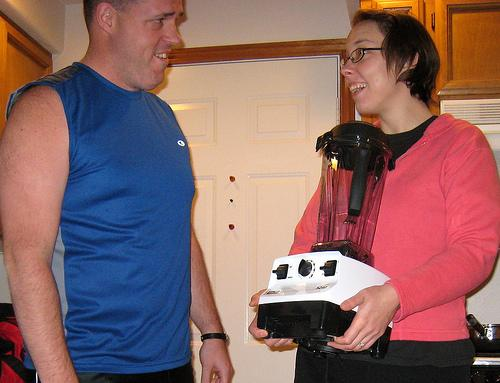Identify the objects near the man and describe their colors. The man is wearing a black watch on his left wrist, and he has on blue shirt with gray trim and black pants. There is a white door with a peep hole and wooden frame behind him. What are the overall emotions of the man and woman in the image, and how can you conclude that? Both the man and woman appear happy and engaged with each other's presence. The man is looking at the woman, while the woman is smiling broadly, indicating a sense of happiness and contentment. Identify any kitchen appliances, furniture or cookware depicted in the image. A black and white blender, a white door behind the people, wood kitchen cabinets, and a saucepan on the stove behind the woman are visible in the image. What can you tell about the apparel of the people in the photograph? A man wearing a blue-gray muscle shirt and a woman in a pink sweater are standing in the kitchen. The woman is wearing glasses and holding an electric blender. How many people are in the image and what are their appearances? There are two people in the image: a woman with short brown hair, glasses, and a pink sweater, and a man with a blue shirt and black pants. They are both standing in a kitchen. Describe the clothing items worn by the woman in the image. The woman is wearing a pink sweatshirt, a black shirt, and a red sweater. She also has on a wedding ring and a pair of eyeglasses. What are the two main colors of the electric blender? The electric blender is primarily black and white. What does the woman seem to be happy about while holding a kitchen appliance? The woman is smiling happily as she holds a black and white electric blender that she may be using in the kitchen. Describe the object that the woman is holding and provide any unique features of it. The woman is holding an electric blender that is black and white with a distinct knob on it. The blender has a white base and black top. Are there any accessories being worn by the woman in the image? List them. Yes, the woman is wearing eye glasses, a ring on her finger, and a wedding ring. Could you tell me if the man is wearing any shoes, specifically red ones? No, it's not mentioned in the image. 